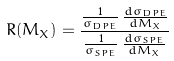Convert formula to latex. <formula><loc_0><loc_0><loc_500><loc_500>R ( M _ { X } ) = \frac { \frac { 1 } { \sigma _ { D P E } } \, \frac { d \sigma _ { D P E } } { d M _ { X } } } { \frac { 1 } { \sigma _ { S P E } } \, \frac { d \sigma _ { S P E } } { d M _ { X } } }</formula> 